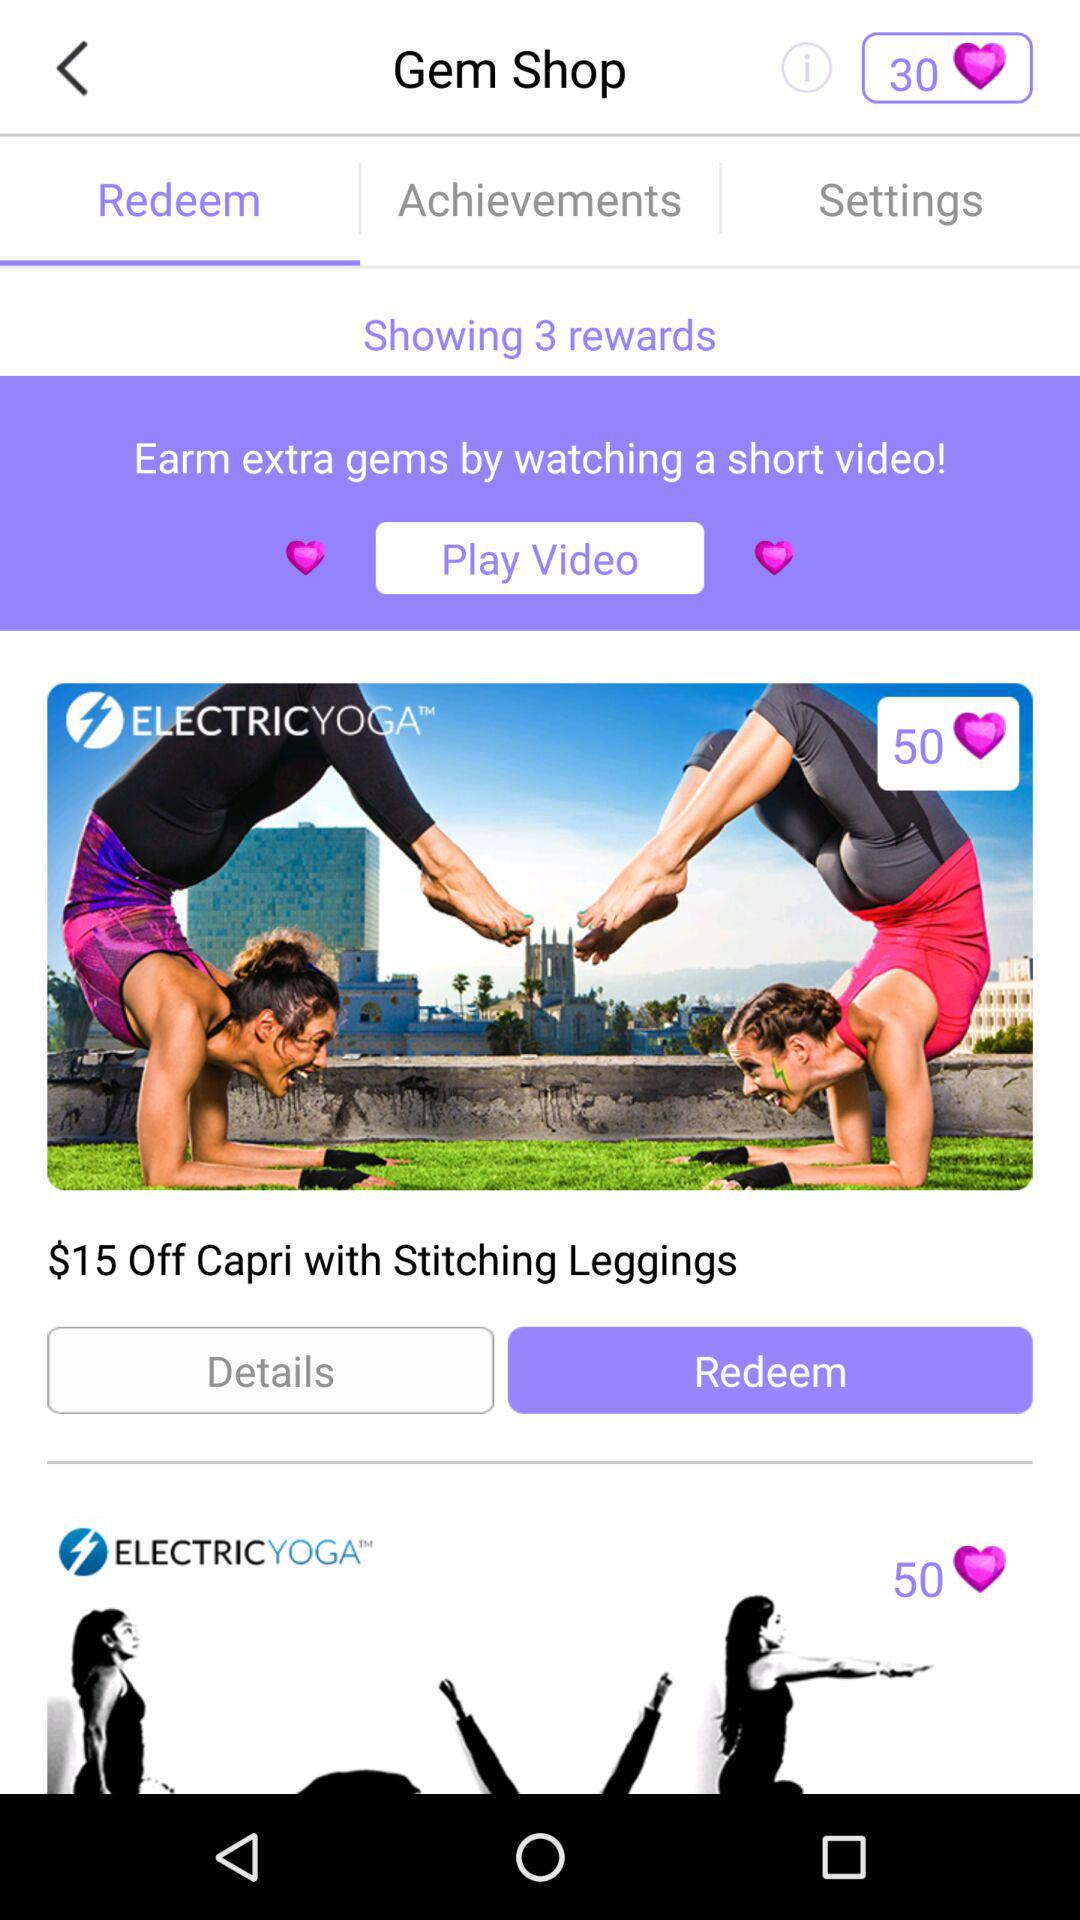How can extra gems be earned? Extra gems can be earned by watching a short video. 